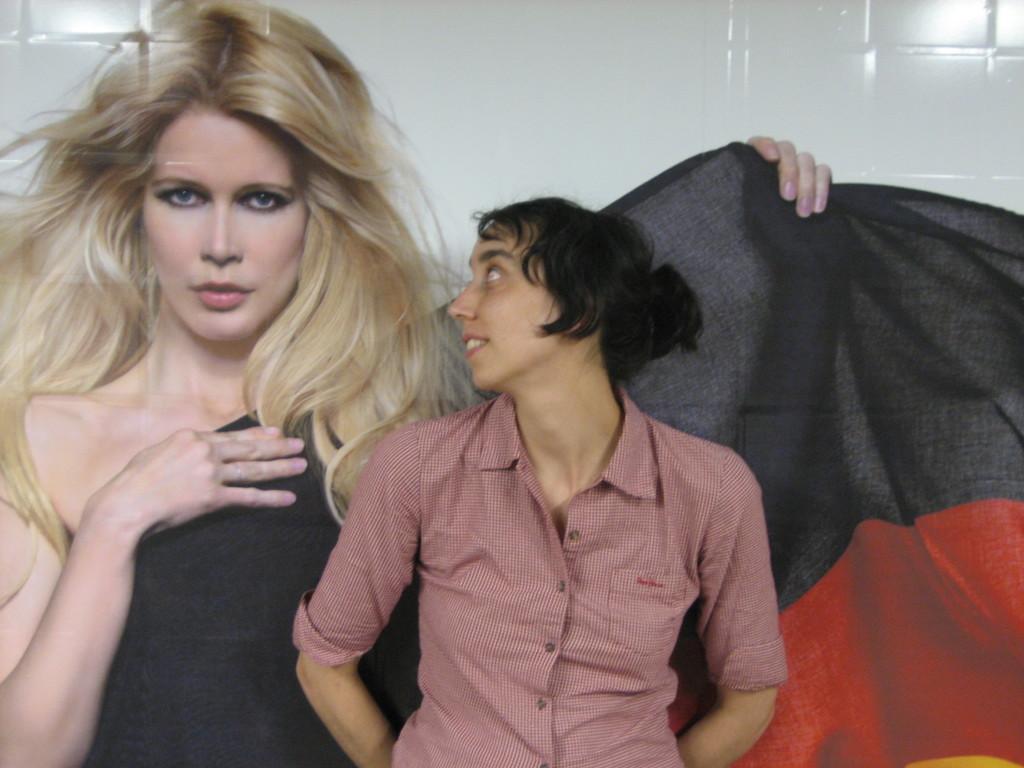How would you summarize this image in a sentence or two? In the middle a woman is standing, she wore a shirt, in the left side it is a picture of a woman, she wore a black color dress, behind them it's a wall which is in white color. 